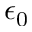Convert formula to latex. <formula><loc_0><loc_0><loc_500><loc_500>\epsilon _ { 0 }</formula> 